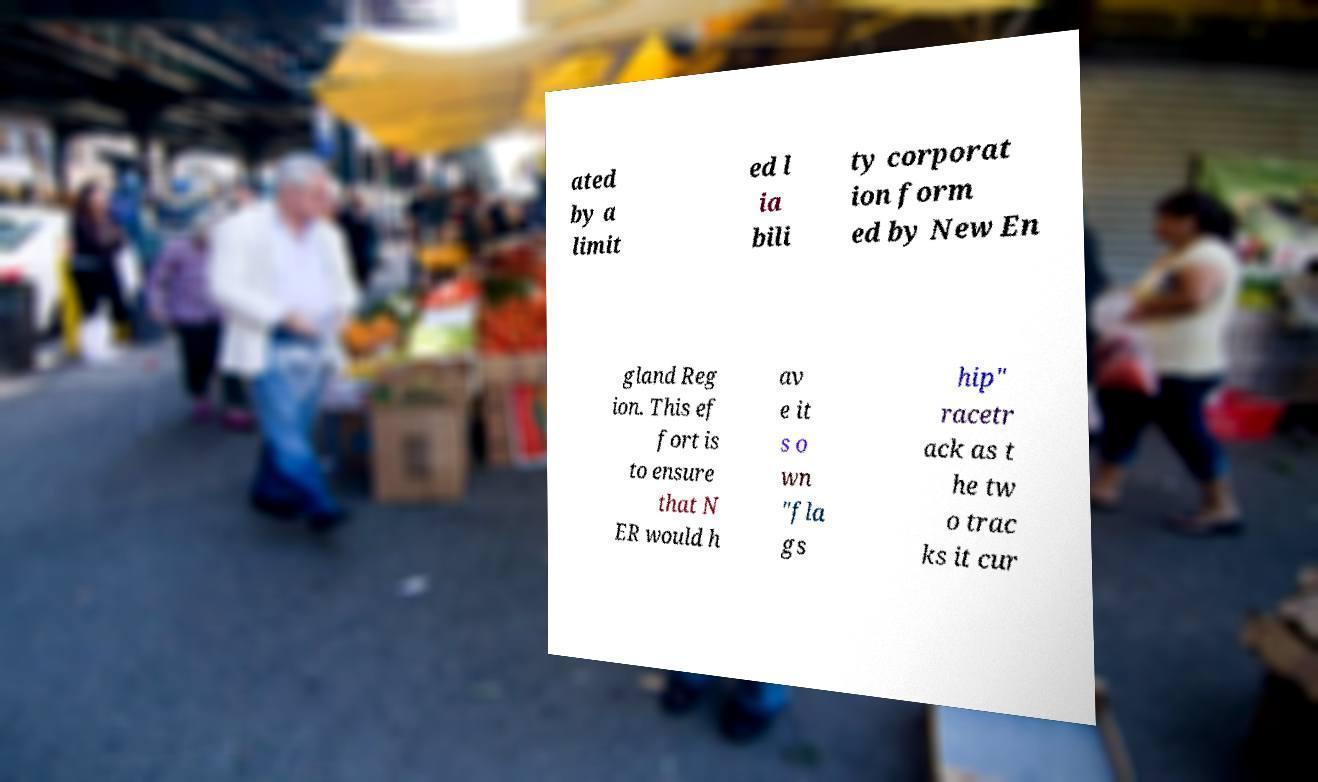Can you read and provide the text displayed in the image?This photo seems to have some interesting text. Can you extract and type it out for me? ated by a limit ed l ia bili ty corporat ion form ed by New En gland Reg ion. This ef fort is to ensure that N ER would h av e it s o wn "fla gs hip" racetr ack as t he tw o trac ks it cur 